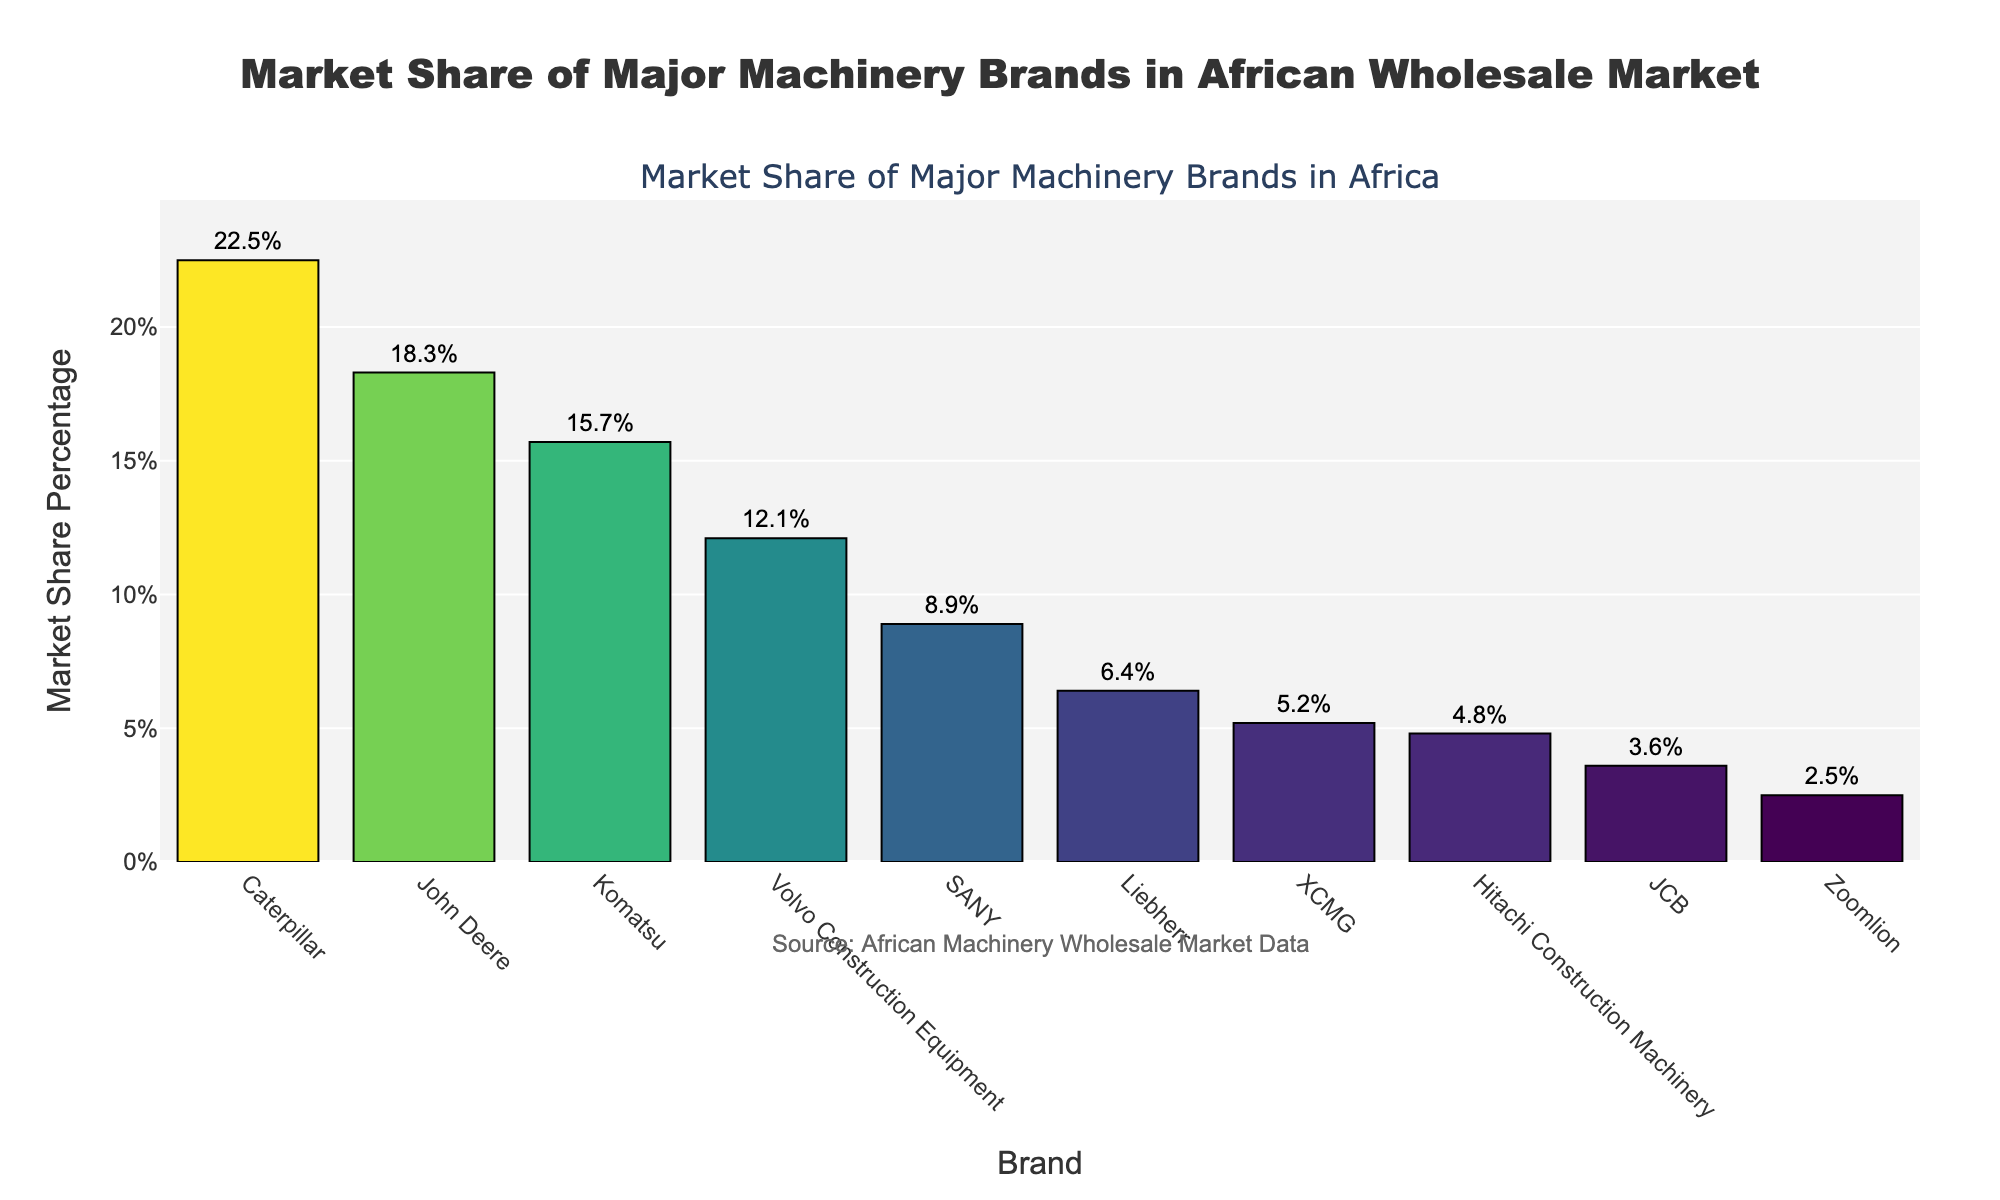Which brand has the highest market share? The bar chart shows the market shares of different brands, with the tallest bar representing the brand with the highest market share. Caterpillar has the tallest bar at 22.5%.
Answer: Caterpillar How much higher is the market share of Caterpillar than SANY? To find the difference between the market shares of Caterpillar and SANY, subtract SANY's market share (8.9%) from Caterpillar's (22.5%). 22.5% - 8.9% = 13.6%.
Answer: 13.6% Which brand has the lowest market share? The bar representing the smallest market share corresponds to the brand Zoomlion, which is at 2.5%.
Answer: Zoomlion What is the combined market share of the top three brands? Add the market shares of Caterpillar (22.5%), John Deere (18.3%), and Komatsu (15.7%). 22.5% + 18.3% + 15.7% = 56.5%.
Answer: 56.5% Is the market share of Volvo Construction Equipment higher than that of Liebherr? Compare the heights of their respective bars. Volvo Construction Equipment has a market share of 12.1%, while Liebherr has 6.4%. 12.1% is greater than 6.4%.
Answer: Yes What is the difference in market share between Hitachi and JCB? Subtract JCB's market share (3.6%) from Hitachi's (4.8%). 4.8% - 3.6% = 1.2%.
Answer: 1.2% What is the average market share of all brands shown? First, sum the market shares of all brands: 22.5% + 18.3% + 15.7% + 12.1% + 8.9% + 6.4% + 5.2% + 4.8% + 3.6% + 2.5% = 100%. Then, divide by the number of brands (10). 100% / 10 = 10%.
Answer: 10% Which brands have a market share of less than 5%? Identify the bars below the 5% mark: XCMG (4.8%), Hitachi Construction Machinery (4.8%), JCB (3.6%), and Zoomlion (2.5%). However, XCMG has 5.2%, thus only Hitachi, JCB, and Zoomlion qualify.
Answer: Hitachi Construction Machinery, JCB, Zoomlion What percentage of the market is held by brands with more than 10% market share? Sum up the market shares of Caterpillar (22.5%), John Deere (18.3%), Komatsu (15.7%), and Volvo Construction Equipment (12.1%). 22.5% + 18.3% + 15.7% + 12.1% = 68.6%.
Answer: 68.6% How does the color intensity of the bar relate to the market share percentage? The color intensity of the bars changes to represent different market share percentages; darker colors indicate a higher share while lighter shades represent lower shares.
Answer: Darker for higher, lighter for lower 